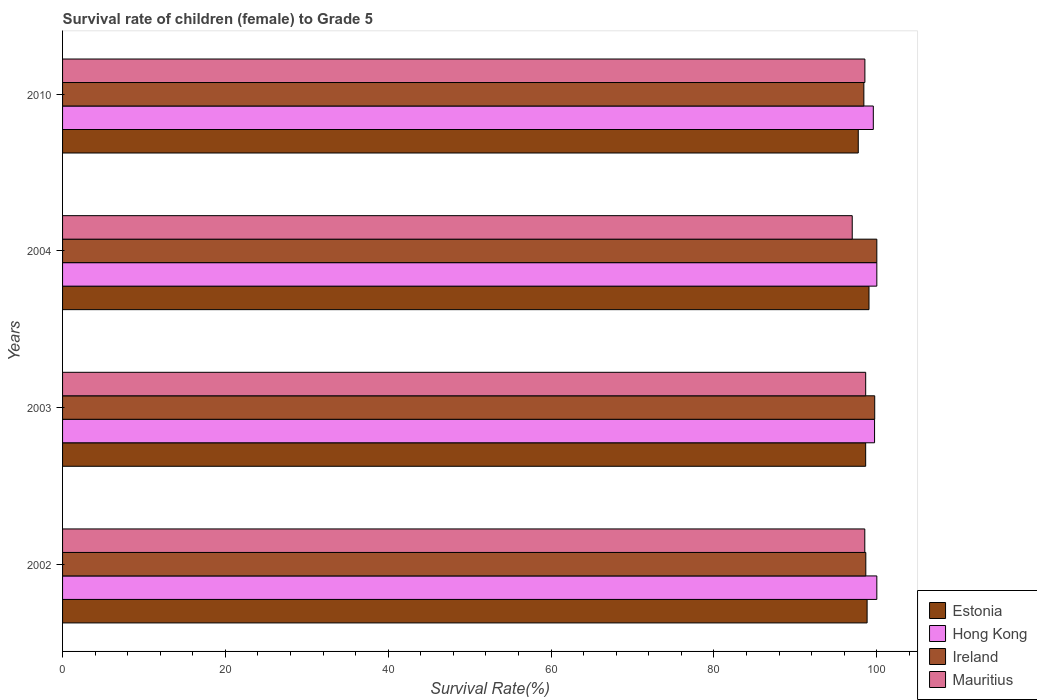Are the number of bars per tick equal to the number of legend labels?
Make the answer very short. Yes. What is the survival rate of female children to grade 5 in Estonia in 2004?
Keep it short and to the point. 99.04. Across all years, what is the minimum survival rate of female children to grade 5 in Ireland?
Give a very brief answer. 98.41. In which year was the survival rate of female children to grade 5 in Estonia maximum?
Keep it short and to the point. 2004. What is the total survival rate of female children to grade 5 in Estonia in the graph?
Ensure brevity in your answer.  394.2. What is the difference between the survival rate of female children to grade 5 in Mauritius in 2002 and that in 2003?
Provide a short and direct response. -0.11. What is the difference between the survival rate of female children to grade 5 in Mauritius in 2004 and the survival rate of female children to grade 5 in Hong Kong in 2010?
Provide a succinct answer. -2.59. What is the average survival rate of female children to grade 5 in Ireland per year?
Ensure brevity in your answer.  99.2. In the year 2010, what is the difference between the survival rate of female children to grade 5 in Estonia and survival rate of female children to grade 5 in Mauritius?
Keep it short and to the point. -0.81. In how many years, is the survival rate of female children to grade 5 in Hong Kong greater than 60 %?
Provide a short and direct response. 4. What is the ratio of the survival rate of female children to grade 5 in Mauritius in 2002 to that in 2004?
Your answer should be very brief. 1.02. Is the difference between the survival rate of female children to grade 5 in Estonia in 2004 and 2010 greater than the difference between the survival rate of female children to grade 5 in Mauritius in 2004 and 2010?
Provide a short and direct response. Yes. What is the difference between the highest and the second highest survival rate of female children to grade 5 in Hong Kong?
Give a very brief answer. 0. What is the difference between the highest and the lowest survival rate of female children to grade 5 in Ireland?
Give a very brief answer. 1.59. Is it the case that in every year, the sum of the survival rate of female children to grade 5 in Hong Kong and survival rate of female children to grade 5 in Mauritius is greater than the sum of survival rate of female children to grade 5 in Ireland and survival rate of female children to grade 5 in Estonia?
Make the answer very short. Yes. What does the 2nd bar from the top in 2002 represents?
Your answer should be compact. Ireland. What does the 4th bar from the bottom in 2003 represents?
Make the answer very short. Mauritius. Is it the case that in every year, the sum of the survival rate of female children to grade 5 in Estonia and survival rate of female children to grade 5 in Mauritius is greater than the survival rate of female children to grade 5 in Ireland?
Give a very brief answer. Yes. How many years are there in the graph?
Make the answer very short. 4. What is the difference between two consecutive major ticks on the X-axis?
Provide a short and direct response. 20. Are the values on the major ticks of X-axis written in scientific E-notation?
Your response must be concise. No. Does the graph contain grids?
Ensure brevity in your answer.  No. How many legend labels are there?
Ensure brevity in your answer.  4. What is the title of the graph?
Provide a succinct answer. Survival rate of children (female) to Grade 5. Does "Niger" appear as one of the legend labels in the graph?
Ensure brevity in your answer.  No. What is the label or title of the X-axis?
Make the answer very short. Survival Rate(%). What is the label or title of the Y-axis?
Your response must be concise. Years. What is the Survival Rate(%) in Estonia in 2002?
Provide a succinct answer. 98.81. What is the Survival Rate(%) in Ireland in 2002?
Make the answer very short. 98.65. What is the Survival Rate(%) of Mauritius in 2002?
Provide a succinct answer. 98.52. What is the Survival Rate(%) in Estonia in 2003?
Your answer should be very brief. 98.63. What is the Survival Rate(%) in Hong Kong in 2003?
Ensure brevity in your answer.  99.72. What is the Survival Rate(%) of Ireland in 2003?
Provide a short and direct response. 99.74. What is the Survival Rate(%) in Mauritius in 2003?
Provide a succinct answer. 98.63. What is the Survival Rate(%) of Estonia in 2004?
Provide a short and direct response. 99.04. What is the Survival Rate(%) of Ireland in 2004?
Provide a succinct answer. 100. What is the Survival Rate(%) of Mauritius in 2004?
Make the answer very short. 96.98. What is the Survival Rate(%) in Estonia in 2010?
Offer a very short reply. 97.72. What is the Survival Rate(%) in Hong Kong in 2010?
Your response must be concise. 99.57. What is the Survival Rate(%) of Ireland in 2010?
Give a very brief answer. 98.41. What is the Survival Rate(%) in Mauritius in 2010?
Provide a short and direct response. 98.53. Across all years, what is the maximum Survival Rate(%) of Estonia?
Keep it short and to the point. 99.04. Across all years, what is the maximum Survival Rate(%) of Mauritius?
Make the answer very short. 98.63. Across all years, what is the minimum Survival Rate(%) in Estonia?
Offer a very short reply. 97.72. Across all years, what is the minimum Survival Rate(%) in Hong Kong?
Provide a short and direct response. 99.57. Across all years, what is the minimum Survival Rate(%) of Ireland?
Ensure brevity in your answer.  98.41. Across all years, what is the minimum Survival Rate(%) of Mauritius?
Offer a terse response. 96.98. What is the total Survival Rate(%) in Estonia in the graph?
Offer a very short reply. 394.2. What is the total Survival Rate(%) in Hong Kong in the graph?
Provide a short and direct response. 399.29. What is the total Survival Rate(%) in Ireland in the graph?
Make the answer very short. 396.79. What is the total Survival Rate(%) of Mauritius in the graph?
Keep it short and to the point. 392.67. What is the difference between the Survival Rate(%) in Estonia in 2002 and that in 2003?
Your answer should be very brief. 0.18. What is the difference between the Survival Rate(%) of Hong Kong in 2002 and that in 2003?
Provide a short and direct response. 0.28. What is the difference between the Survival Rate(%) in Ireland in 2002 and that in 2003?
Keep it short and to the point. -1.09. What is the difference between the Survival Rate(%) in Mauritius in 2002 and that in 2003?
Keep it short and to the point. -0.11. What is the difference between the Survival Rate(%) of Estonia in 2002 and that in 2004?
Your answer should be very brief. -0.23. What is the difference between the Survival Rate(%) in Ireland in 2002 and that in 2004?
Make the answer very short. -1.35. What is the difference between the Survival Rate(%) of Mauritius in 2002 and that in 2004?
Your response must be concise. 1.54. What is the difference between the Survival Rate(%) in Estonia in 2002 and that in 2010?
Offer a very short reply. 1.09. What is the difference between the Survival Rate(%) of Hong Kong in 2002 and that in 2010?
Make the answer very short. 0.43. What is the difference between the Survival Rate(%) of Ireland in 2002 and that in 2010?
Give a very brief answer. 0.24. What is the difference between the Survival Rate(%) in Mauritius in 2002 and that in 2010?
Provide a succinct answer. -0.01. What is the difference between the Survival Rate(%) in Estonia in 2003 and that in 2004?
Your answer should be compact. -0.41. What is the difference between the Survival Rate(%) in Hong Kong in 2003 and that in 2004?
Your answer should be compact. -0.28. What is the difference between the Survival Rate(%) in Ireland in 2003 and that in 2004?
Your response must be concise. -0.26. What is the difference between the Survival Rate(%) of Mauritius in 2003 and that in 2004?
Make the answer very short. 1.65. What is the difference between the Survival Rate(%) of Estonia in 2003 and that in 2010?
Make the answer very short. 0.91. What is the difference between the Survival Rate(%) of Hong Kong in 2003 and that in 2010?
Keep it short and to the point. 0.15. What is the difference between the Survival Rate(%) in Ireland in 2003 and that in 2010?
Make the answer very short. 1.33. What is the difference between the Survival Rate(%) in Mauritius in 2003 and that in 2010?
Make the answer very short. 0.1. What is the difference between the Survival Rate(%) in Estonia in 2004 and that in 2010?
Provide a short and direct response. 1.32. What is the difference between the Survival Rate(%) in Hong Kong in 2004 and that in 2010?
Offer a terse response. 0.43. What is the difference between the Survival Rate(%) in Ireland in 2004 and that in 2010?
Your response must be concise. 1.59. What is the difference between the Survival Rate(%) in Mauritius in 2004 and that in 2010?
Offer a terse response. -1.55. What is the difference between the Survival Rate(%) in Estonia in 2002 and the Survival Rate(%) in Hong Kong in 2003?
Give a very brief answer. -0.91. What is the difference between the Survival Rate(%) of Estonia in 2002 and the Survival Rate(%) of Ireland in 2003?
Provide a succinct answer. -0.93. What is the difference between the Survival Rate(%) in Estonia in 2002 and the Survival Rate(%) in Mauritius in 2003?
Make the answer very short. 0.17. What is the difference between the Survival Rate(%) in Hong Kong in 2002 and the Survival Rate(%) in Ireland in 2003?
Offer a very short reply. 0.26. What is the difference between the Survival Rate(%) in Hong Kong in 2002 and the Survival Rate(%) in Mauritius in 2003?
Offer a very short reply. 1.37. What is the difference between the Survival Rate(%) in Ireland in 2002 and the Survival Rate(%) in Mauritius in 2003?
Your answer should be very brief. 0.01. What is the difference between the Survival Rate(%) in Estonia in 2002 and the Survival Rate(%) in Hong Kong in 2004?
Keep it short and to the point. -1.19. What is the difference between the Survival Rate(%) of Estonia in 2002 and the Survival Rate(%) of Ireland in 2004?
Keep it short and to the point. -1.19. What is the difference between the Survival Rate(%) in Estonia in 2002 and the Survival Rate(%) in Mauritius in 2004?
Offer a very short reply. 1.83. What is the difference between the Survival Rate(%) of Hong Kong in 2002 and the Survival Rate(%) of Mauritius in 2004?
Keep it short and to the point. 3.02. What is the difference between the Survival Rate(%) of Ireland in 2002 and the Survival Rate(%) of Mauritius in 2004?
Give a very brief answer. 1.67. What is the difference between the Survival Rate(%) of Estonia in 2002 and the Survival Rate(%) of Hong Kong in 2010?
Provide a succinct answer. -0.76. What is the difference between the Survival Rate(%) in Estonia in 2002 and the Survival Rate(%) in Ireland in 2010?
Your response must be concise. 0.4. What is the difference between the Survival Rate(%) in Estonia in 2002 and the Survival Rate(%) in Mauritius in 2010?
Keep it short and to the point. 0.27. What is the difference between the Survival Rate(%) of Hong Kong in 2002 and the Survival Rate(%) of Ireland in 2010?
Your response must be concise. 1.59. What is the difference between the Survival Rate(%) of Hong Kong in 2002 and the Survival Rate(%) of Mauritius in 2010?
Keep it short and to the point. 1.47. What is the difference between the Survival Rate(%) in Ireland in 2002 and the Survival Rate(%) in Mauritius in 2010?
Give a very brief answer. 0.11. What is the difference between the Survival Rate(%) of Estonia in 2003 and the Survival Rate(%) of Hong Kong in 2004?
Give a very brief answer. -1.37. What is the difference between the Survival Rate(%) in Estonia in 2003 and the Survival Rate(%) in Ireland in 2004?
Ensure brevity in your answer.  -1.37. What is the difference between the Survival Rate(%) in Estonia in 2003 and the Survival Rate(%) in Mauritius in 2004?
Offer a very short reply. 1.65. What is the difference between the Survival Rate(%) of Hong Kong in 2003 and the Survival Rate(%) of Ireland in 2004?
Your answer should be very brief. -0.28. What is the difference between the Survival Rate(%) in Hong Kong in 2003 and the Survival Rate(%) in Mauritius in 2004?
Keep it short and to the point. 2.74. What is the difference between the Survival Rate(%) of Ireland in 2003 and the Survival Rate(%) of Mauritius in 2004?
Offer a very short reply. 2.76. What is the difference between the Survival Rate(%) of Estonia in 2003 and the Survival Rate(%) of Hong Kong in 2010?
Your answer should be compact. -0.94. What is the difference between the Survival Rate(%) in Estonia in 2003 and the Survival Rate(%) in Ireland in 2010?
Offer a terse response. 0.22. What is the difference between the Survival Rate(%) of Estonia in 2003 and the Survival Rate(%) of Mauritius in 2010?
Give a very brief answer. 0.1. What is the difference between the Survival Rate(%) in Hong Kong in 2003 and the Survival Rate(%) in Ireland in 2010?
Your response must be concise. 1.31. What is the difference between the Survival Rate(%) of Hong Kong in 2003 and the Survival Rate(%) of Mauritius in 2010?
Offer a very short reply. 1.19. What is the difference between the Survival Rate(%) in Ireland in 2003 and the Survival Rate(%) in Mauritius in 2010?
Offer a very short reply. 1.21. What is the difference between the Survival Rate(%) in Estonia in 2004 and the Survival Rate(%) in Hong Kong in 2010?
Provide a succinct answer. -0.53. What is the difference between the Survival Rate(%) in Estonia in 2004 and the Survival Rate(%) in Ireland in 2010?
Provide a short and direct response. 0.63. What is the difference between the Survival Rate(%) of Estonia in 2004 and the Survival Rate(%) of Mauritius in 2010?
Keep it short and to the point. 0.5. What is the difference between the Survival Rate(%) of Hong Kong in 2004 and the Survival Rate(%) of Ireland in 2010?
Give a very brief answer. 1.59. What is the difference between the Survival Rate(%) of Hong Kong in 2004 and the Survival Rate(%) of Mauritius in 2010?
Provide a succinct answer. 1.47. What is the difference between the Survival Rate(%) in Ireland in 2004 and the Survival Rate(%) in Mauritius in 2010?
Keep it short and to the point. 1.47. What is the average Survival Rate(%) of Estonia per year?
Your answer should be very brief. 98.55. What is the average Survival Rate(%) in Hong Kong per year?
Give a very brief answer. 99.82. What is the average Survival Rate(%) in Ireland per year?
Give a very brief answer. 99.2. What is the average Survival Rate(%) in Mauritius per year?
Ensure brevity in your answer.  98.17. In the year 2002, what is the difference between the Survival Rate(%) in Estonia and Survival Rate(%) in Hong Kong?
Ensure brevity in your answer.  -1.19. In the year 2002, what is the difference between the Survival Rate(%) in Estonia and Survival Rate(%) in Ireland?
Offer a terse response. 0.16. In the year 2002, what is the difference between the Survival Rate(%) of Estonia and Survival Rate(%) of Mauritius?
Provide a short and direct response. 0.28. In the year 2002, what is the difference between the Survival Rate(%) in Hong Kong and Survival Rate(%) in Ireland?
Make the answer very short. 1.35. In the year 2002, what is the difference between the Survival Rate(%) of Hong Kong and Survival Rate(%) of Mauritius?
Provide a short and direct response. 1.48. In the year 2002, what is the difference between the Survival Rate(%) of Ireland and Survival Rate(%) of Mauritius?
Your answer should be very brief. 0.12. In the year 2003, what is the difference between the Survival Rate(%) in Estonia and Survival Rate(%) in Hong Kong?
Your answer should be compact. -1.09. In the year 2003, what is the difference between the Survival Rate(%) in Estonia and Survival Rate(%) in Ireland?
Keep it short and to the point. -1.11. In the year 2003, what is the difference between the Survival Rate(%) in Estonia and Survival Rate(%) in Mauritius?
Offer a very short reply. -0. In the year 2003, what is the difference between the Survival Rate(%) of Hong Kong and Survival Rate(%) of Ireland?
Your answer should be very brief. -0.02. In the year 2003, what is the difference between the Survival Rate(%) of Hong Kong and Survival Rate(%) of Mauritius?
Give a very brief answer. 1.09. In the year 2003, what is the difference between the Survival Rate(%) in Ireland and Survival Rate(%) in Mauritius?
Provide a short and direct response. 1.11. In the year 2004, what is the difference between the Survival Rate(%) in Estonia and Survival Rate(%) in Hong Kong?
Provide a succinct answer. -0.96. In the year 2004, what is the difference between the Survival Rate(%) in Estonia and Survival Rate(%) in Ireland?
Make the answer very short. -0.96. In the year 2004, what is the difference between the Survival Rate(%) in Estonia and Survival Rate(%) in Mauritius?
Your response must be concise. 2.06. In the year 2004, what is the difference between the Survival Rate(%) of Hong Kong and Survival Rate(%) of Ireland?
Provide a succinct answer. 0. In the year 2004, what is the difference between the Survival Rate(%) of Hong Kong and Survival Rate(%) of Mauritius?
Give a very brief answer. 3.02. In the year 2004, what is the difference between the Survival Rate(%) in Ireland and Survival Rate(%) in Mauritius?
Your answer should be very brief. 3.02. In the year 2010, what is the difference between the Survival Rate(%) of Estonia and Survival Rate(%) of Hong Kong?
Make the answer very short. -1.85. In the year 2010, what is the difference between the Survival Rate(%) in Estonia and Survival Rate(%) in Ireland?
Ensure brevity in your answer.  -0.69. In the year 2010, what is the difference between the Survival Rate(%) in Estonia and Survival Rate(%) in Mauritius?
Give a very brief answer. -0.81. In the year 2010, what is the difference between the Survival Rate(%) in Hong Kong and Survival Rate(%) in Ireland?
Provide a short and direct response. 1.16. In the year 2010, what is the difference between the Survival Rate(%) of Hong Kong and Survival Rate(%) of Mauritius?
Keep it short and to the point. 1.04. In the year 2010, what is the difference between the Survival Rate(%) of Ireland and Survival Rate(%) of Mauritius?
Your answer should be very brief. -0.13. What is the ratio of the Survival Rate(%) of Hong Kong in 2002 to that in 2003?
Offer a very short reply. 1. What is the ratio of the Survival Rate(%) in Mauritius in 2002 to that in 2003?
Give a very brief answer. 1. What is the ratio of the Survival Rate(%) of Estonia in 2002 to that in 2004?
Ensure brevity in your answer.  1. What is the ratio of the Survival Rate(%) of Ireland in 2002 to that in 2004?
Your response must be concise. 0.99. What is the ratio of the Survival Rate(%) in Mauritius in 2002 to that in 2004?
Your response must be concise. 1.02. What is the ratio of the Survival Rate(%) in Estonia in 2002 to that in 2010?
Ensure brevity in your answer.  1.01. What is the ratio of the Survival Rate(%) in Mauritius in 2002 to that in 2010?
Make the answer very short. 1. What is the ratio of the Survival Rate(%) in Estonia in 2003 to that in 2004?
Your answer should be very brief. 1. What is the ratio of the Survival Rate(%) in Hong Kong in 2003 to that in 2004?
Your answer should be very brief. 1. What is the ratio of the Survival Rate(%) in Ireland in 2003 to that in 2004?
Your answer should be very brief. 1. What is the ratio of the Survival Rate(%) of Estonia in 2003 to that in 2010?
Ensure brevity in your answer.  1.01. What is the ratio of the Survival Rate(%) of Ireland in 2003 to that in 2010?
Give a very brief answer. 1.01. What is the ratio of the Survival Rate(%) of Mauritius in 2003 to that in 2010?
Provide a short and direct response. 1. What is the ratio of the Survival Rate(%) in Estonia in 2004 to that in 2010?
Your response must be concise. 1.01. What is the ratio of the Survival Rate(%) in Ireland in 2004 to that in 2010?
Ensure brevity in your answer.  1.02. What is the ratio of the Survival Rate(%) of Mauritius in 2004 to that in 2010?
Ensure brevity in your answer.  0.98. What is the difference between the highest and the second highest Survival Rate(%) in Estonia?
Provide a succinct answer. 0.23. What is the difference between the highest and the second highest Survival Rate(%) in Ireland?
Keep it short and to the point. 0.26. What is the difference between the highest and the second highest Survival Rate(%) in Mauritius?
Make the answer very short. 0.1. What is the difference between the highest and the lowest Survival Rate(%) of Estonia?
Keep it short and to the point. 1.32. What is the difference between the highest and the lowest Survival Rate(%) in Hong Kong?
Your answer should be compact. 0.43. What is the difference between the highest and the lowest Survival Rate(%) in Ireland?
Your answer should be very brief. 1.59. What is the difference between the highest and the lowest Survival Rate(%) of Mauritius?
Keep it short and to the point. 1.65. 